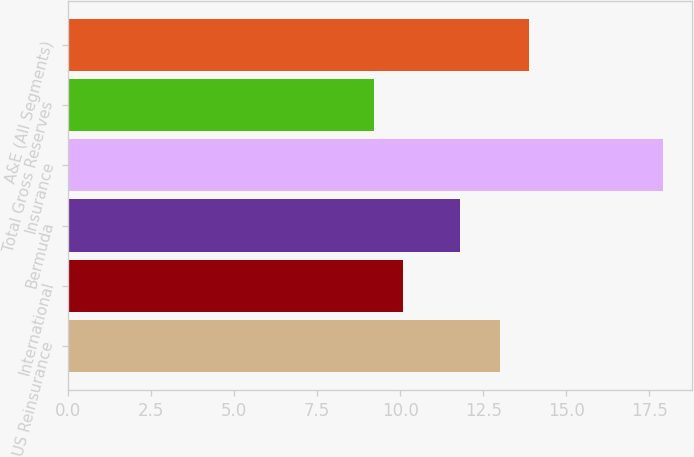Convert chart. <chart><loc_0><loc_0><loc_500><loc_500><bar_chart><fcel>US Reinsurance<fcel>International<fcel>Bermuda<fcel>Insurance<fcel>Total Gross Reserves<fcel>A&E (All Segments)<nl><fcel>13<fcel>10.07<fcel>11.81<fcel>17.9<fcel>9.2<fcel>13.87<nl></chart> 